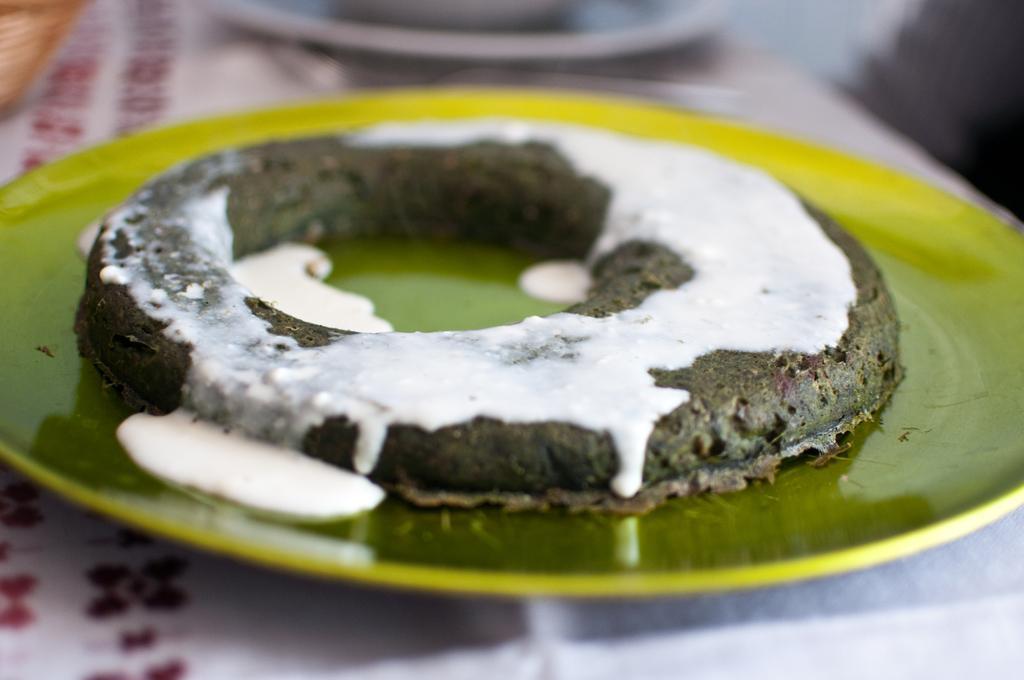Could you give a brief overview of what you see in this image? In the picture we can see a table on it, we can see a green color plate with a food item with some white color cream on it and behind the plate we can see another plate which is not clearly visible. 